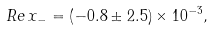<formula> <loc_0><loc_0><loc_500><loc_500>R e \, x _ { - } = \left ( - 0 . 8 \pm 2 . 5 \right ) \times 1 0 ^ { - 3 } ,</formula> 